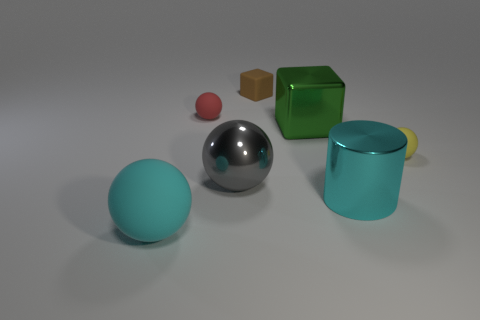What is the color of the small cube?
Give a very brief answer. Brown. There is a yellow rubber sphere; is its size the same as the matte object that is in front of the yellow matte sphere?
Ensure brevity in your answer.  No. What number of shiny things are either red cylinders or small yellow balls?
Offer a terse response. 0. Is there anything else that has the same material as the small block?
Provide a short and direct response. Yes. Does the metallic cube have the same color as the big shiny thing in front of the gray sphere?
Make the answer very short. No. What shape is the large green metal object?
Give a very brief answer. Cube. What size is the rubber thing that is to the right of the large metal object behind the small ball on the right side of the tiny brown rubber cube?
Make the answer very short. Small. What number of other objects are the same shape as the red thing?
Your answer should be compact. 3. There is a object right of the large cyan metallic cylinder; is its shape the same as the big cyan object that is to the right of the large cyan rubber object?
Your answer should be compact. No. How many cubes are either tiny gray metallic things or green metallic objects?
Give a very brief answer. 1. 